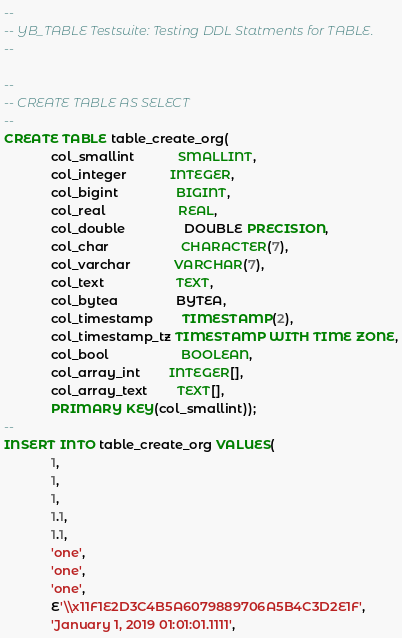<code> <loc_0><loc_0><loc_500><loc_500><_SQL_>--
-- YB_TABLE Testsuite: Testing DDL Statments for TABLE.
--

--
-- CREATE TABLE AS SELECT
--
CREATE TABLE table_create_org(
			 col_smallint			SMALLINT,
			 col_integer			INTEGER,
			 col_bigint				BIGINT,
			 col_real					REAL,
			 col_double				DOUBLE PRECISION,
			 col_char					CHARACTER(7),
			 col_varchar			VARCHAR(7),
			 col_text					TEXT,
			 col_bytea				BYTEA,
			 col_timestamp		TIMESTAMP(2),
			 col_timestamp_tz TIMESTAMP WITH TIME ZONE,
			 col_bool					BOOLEAN,
			 col_array_int		INTEGER[],
			 col_array_text		TEXT[],
			 PRIMARY KEY(col_smallint));
--
INSERT INTO table_create_org VALUES(
			 1,
			 1,
			 1,
			 1.1,
			 1.1,
			 'one',
			 'one',
			 'one',
			 E'\\x11F1E2D3C4B5A6079889706A5B4C3D2E1F',
			 'January 1, 2019 01:01:01.1111',</code> 